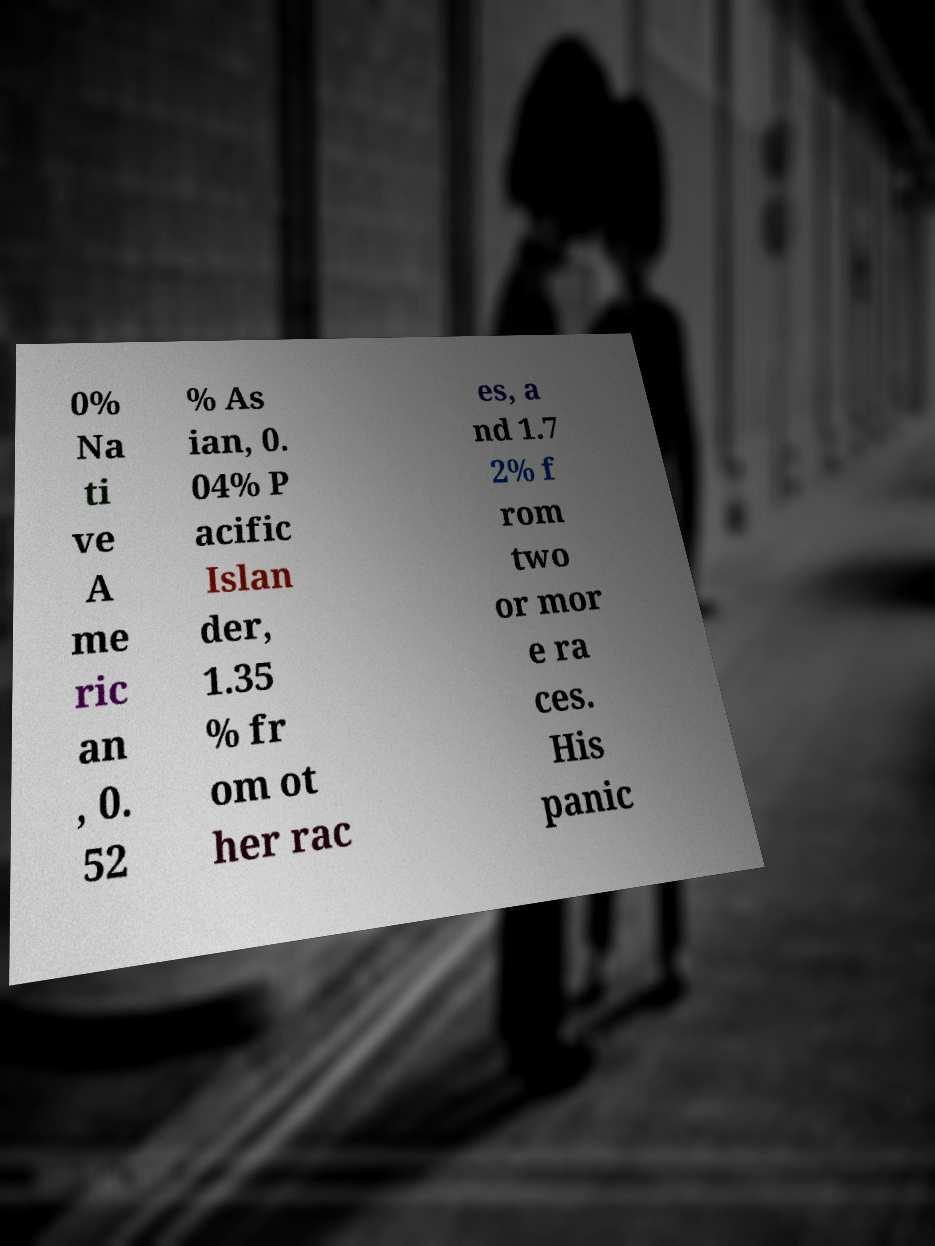Could you extract and type out the text from this image? 0% Na ti ve A me ric an , 0. 52 % As ian, 0. 04% P acific Islan der, 1.35 % fr om ot her rac es, a nd 1.7 2% f rom two or mor e ra ces. His panic 